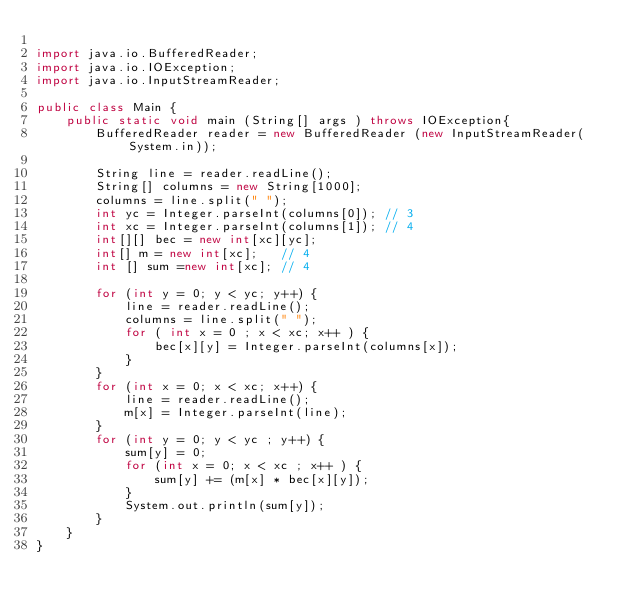<code> <loc_0><loc_0><loc_500><loc_500><_Java_>
import java.io.BufferedReader;
import java.io.IOException;
import java.io.InputStreamReader;

public class Main {
    public static void main (String[] args ) throws IOException{
        BufferedReader reader = new BufferedReader (new InputStreamReader(System.in));
        
        String line = reader.readLine();
        String[] columns = new String[1000];
        columns = line.split(" ");
        int yc = Integer.parseInt(columns[0]); // 3
        int xc = Integer.parseInt(columns[1]); // 4
        int[][] bec = new int[xc][yc];
        int[] m = new int[xc];   // 4
        int [] sum =new int[xc]; // 4
        
        for (int y = 0; y < yc; y++) {
            line = reader.readLine();
            columns = line.split(" ");
            for ( int x = 0 ; x < xc; x++ ) {
                bec[x][y] = Integer.parseInt(columns[x]);
            }
        }
        for (int x = 0; x < xc; x++) {
            line = reader.readLine();
            m[x] = Integer.parseInt(line);
        }
        for (int y = 0; y < yc ; y++) {
            sum[y] = 0;
            for (int x = 0; x < xc ; x++ ) {
                sum[y] += (m[x] * bec[x][y]);
            }
            System.out.println(sum[y]);
        }
    }
}</code> 